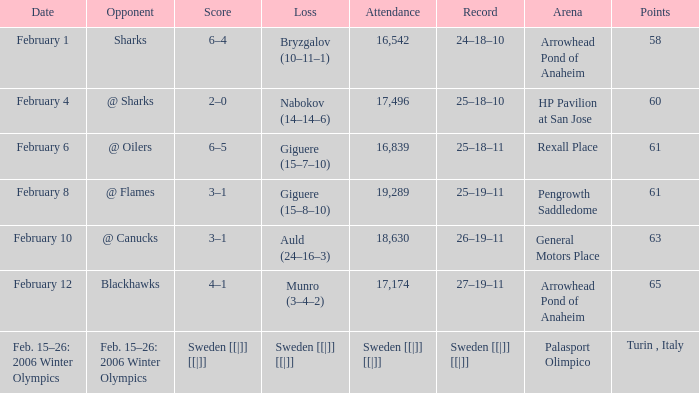What is the points when the score was 3–1, and record was 25–19–11? 61.0. 